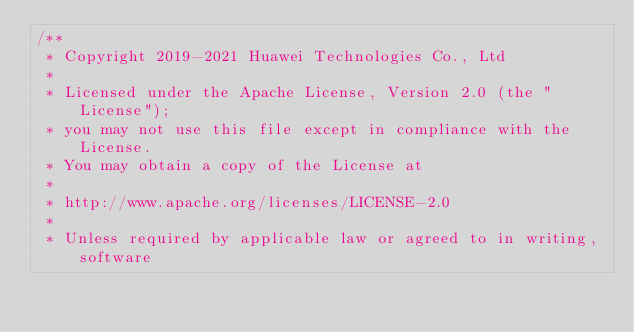Convert code to text. <code><loc_0><loc_0><loc_500><loc_500><_C++_>/**
 * Copyright 2019-2021 Huawei Technologies Co., Ltd
 *
 * Licensed under the Apache License, Version 2.0 (the "License");
 * you may not use this file except in compliance with the License.
 * You may obtain a copy of the License at
 *
 * http://www.apache.org/licenses/LICENSE-2.0
 *
 * Unless required by applicable law or agreed to in writing, software</code> 